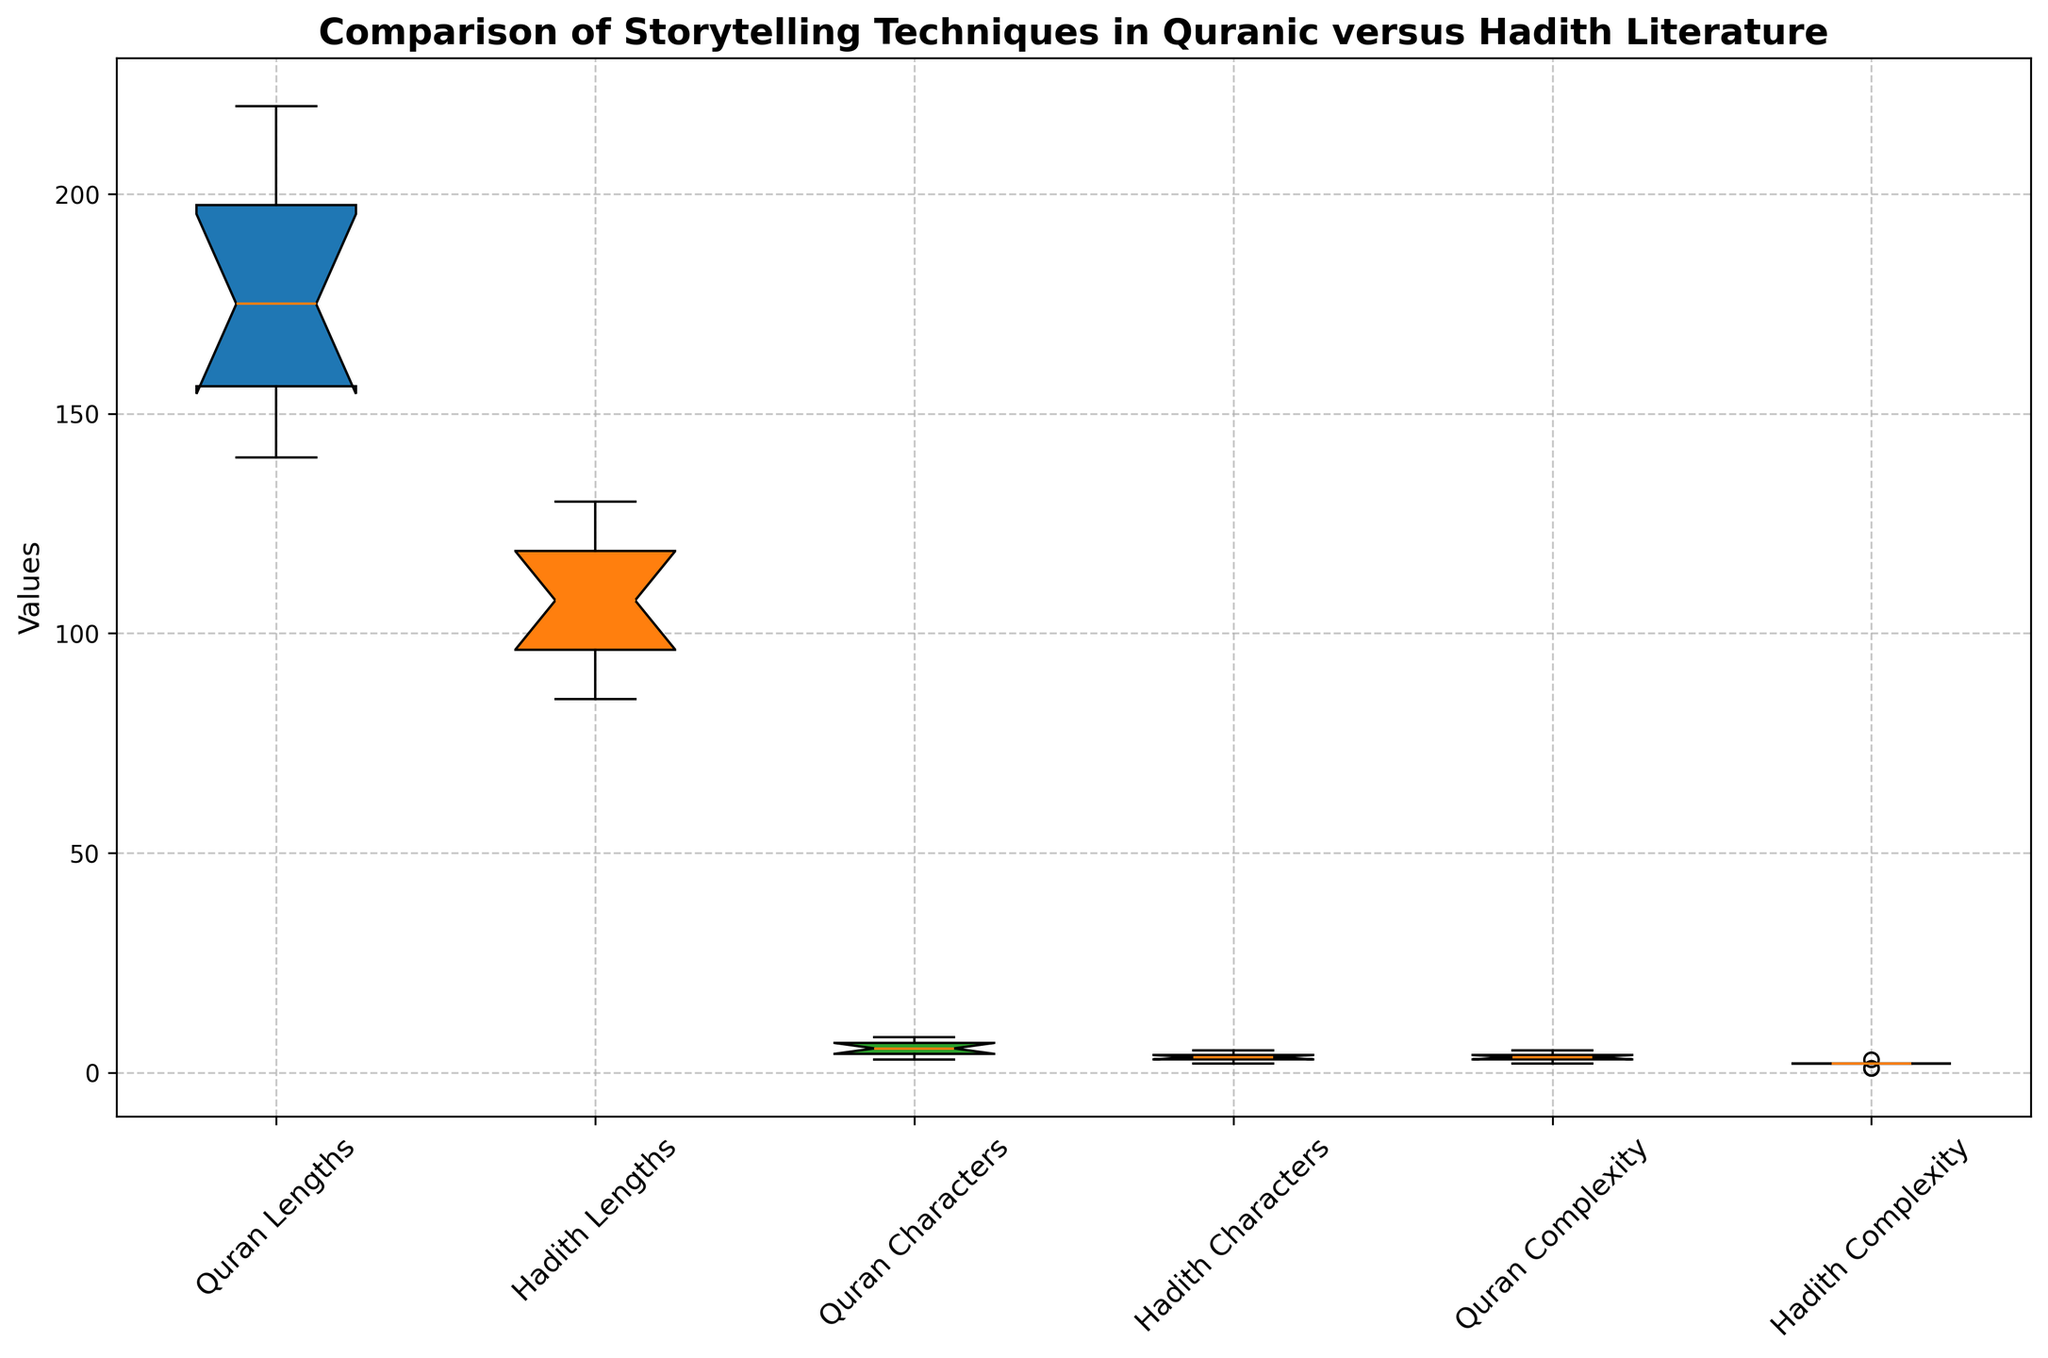Which literary work, Quranic or Hadith, has stories with generally longer lengths? By looking at the box plot, the median length of the stories can be compared. The Quranic stories' box for 'Length of Story' is positioned higher than the Hadith stories' box, indicating longer story lengths in general.
Answer: Quranic Which literary work has a higher number of characters in its stories? The box plot for 'Number of Characters' shows that Quranic stories generally have more characters since its box is positioned higher than the Hadith stories' corresponding box.
Answer: Quranic What is the median theme complexity for Hadith literature and how does it compare to Quranic literature? The box plot shows the median of 'Theme Complexity' for Hadith literature at approximately the 2nd quartile, compared to Quranic literature where the median falls around the 4th quartile. Therefore, Quranic literature has higher median theme complexity.
Answer: Hadith (2) versus Quranic (4) Which group has more variability in the length of stories? By comparing the interquartile ranges (IQR) for 'Length of Story', Quranic literature shows a larger IQR, indicating greater variability compared to Hadith literature.
Answer: Quranic Are the number of characters in Hadith stories more consistent than in Quranic stories? The narrower interquartile range (IQR) for 'Number of Characters' in Hadith literature suggests a more consistent number of characters compared to the wider IQR in Quranic literature.
Answer: Yes Which data set shows a higher maximum value for ‘Theme Complexity’? By observing the highest whisker in the 'Theme Complexity' box plots, the maximum complexity value for Quranic literature is higher compared to Hadith literature.
Answer: Quranic Does Quranic literature present more varied theme complexity? Examining the interquartile range (IQR) for 'Theme Complexity', Quranic literature displays more variation due to a wider IQR compared to Hadith literature.
Answer: Yes Which group has a lower first quartile for the length of stories? By checking the first quartile marks in 'Length of Story', the Hadith literature has a lower first quartile value compared to Quranic literature.
Answer: Hadith What is the range (difference between maximum and minimum values) for the number of characters in Quranic stories? Observing the whiskers in the 'Number of Characters' for Quranic stories, the range is calculated as approximately 8 (max) - 3 (min), resulting in a range of 5.
Answer: 5 Which group shows more outliers in their data sets? The box plot does not indicate any visible outliers in 'Length of Story', 'Number of Characters', or 'Theme Complexity' for either Quranic or Hadith datasets.
Answer: Neither 